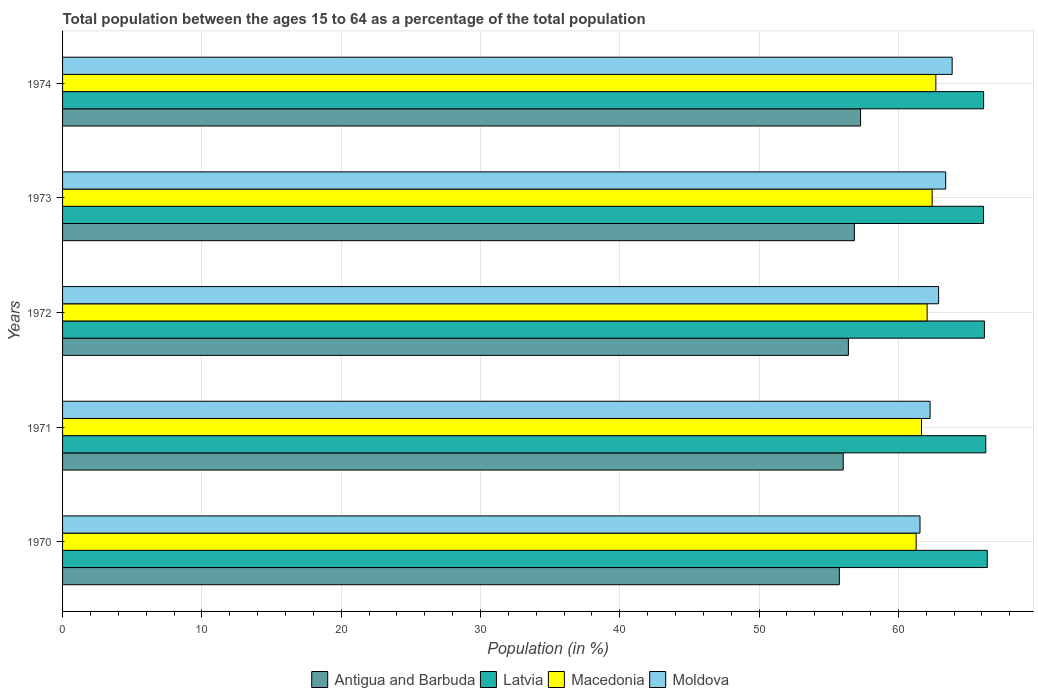How many groups of bars are there?
Offer a terse response. 5. Are the number of bars per tick equal to the number of legend labels?
Give a very brief answer. Yes. How many bars are there on the 2nd tick from the bottom?
Ensure brevity in your answer.  4. What is the label of the 4th group of bars from the top?
Ensure brevity in your answer.  1971. What is the percentage of the population ages 15 to 64 in Macedonia in 1972?
Offer a terse response. 62.07. Across all years, what is the maximum percentage of the population ages 15 to 64 in Moldova?
Offer a terse response. 63.86. Across all years, what is the minimum percentage of the population ages 15 to 64 in Latvia?
Your answer should be very brief. 66.12. In which year was the percentage of the population ages 15 to 64 in Latvia maximum?
Make the answer very short. 1970. What is the total percentage of the population ages 15 to 64 in Macedonia in the graph?
Provide a short and direct response. 310.12. What is the difference between the percentage of the population ages 15 to 64 in Latvia in 1970 and that in 1973?
Provide a succinct answer. 0.27. What is the difference between the percentage of the population ages 15 to 64 in Latvia in 1971 and the percentage of the population ages 15 to 64 in Antigua and Barbuda in 1972?
Your response must be concise. 9.86. What is the average percentage of the population ages 15 to 64 in Latvia per year?
Give a very brief answer. 66.21. In the year 1971, what is the difference between the percentage of the population ages 15 to 64 in Moldova and percentage of the population ages 15 to 64 in Latvia?
Ensure brevity in your answer.  -4. What is the ratio of the percentage of the population ages 15 to 64 in Latvia in 1971 to that in 1973?
Make the answer very short. 1. Is the percentage of the population ages 15 to 64 in Moldova in 1970 less than that in 1973?
Your answer should be compact. Yes. What is the difference between the highest and the second highest percentage of the population ages 15 to 64 in Latvia?
Offer a very short reply. 0.11. What is the difference between the highest and the lowest percentage of the population ages 15 to 64 in Antigua and Barbuda?
Keep it short and to the point. 1.52. What does the 3rd bar from the top in 1970 represents?
Offer a very short reply. Latvia. What does the 3rd bar from the bottom in 1972 represents?
Offer a terse response. Macedonia. Are the values on the major ticks of X-axis written in scientific E-notation?
Provide a short and direct response. No. Does the graph contain any zero values?
Keep it short and to the point. No. Does the graph contain grids?
Provide a short and direct response. Yes. How many legend labels are there?
Provide a succinct answer. 4. What is the title of the graph?
Provide a succinct answer. Total population between the ages 15 to 64 as a percentage of the total population. What is the label or title of the X-axis?
Offer a terse response. Population (in %). What is the label or title of the Y-axis?
Your answer should be compact. Years. What is the Population (in %) of Antigua and Barbuda in 1970?
Make the answer very short. 55.76. What is the Population (in %) of Latvia in 1970?
Provide a short and direct response. 66.38. What is the Population (in %) in Macedonia in 1970?
Offer a very short reply. 61.28. What is the Population (in %) in Moldova in 1970?
Give a very brief answer. 61.55. What is the Population (in %) in Antigua and Barbuda in 1971?
Give a very brief answer. 56.04. What is the Population (in %) in Latvia in 1971?
Make the answer very short. 66.28. What is the Population (in %) in Macedonia in 1971?
Make the answer very short. 61.66. What is the Population (in %) in Moldova in 1971?
Give a very brief answer. 62.28. What is the Population (in %) in Antigua and Barbuda in 1972?
Provide a short and direct response. 56.41. What is the Population (in %) of Latvia in 1972?
Offer a very short reply. 66.18. What is the Population (in %) of Macedonia in 1972?
Make the answer very short. 62.07. What is the Population (in %) in Moldova in 1972?
Offer a very short reply. 62.89. What is the Population (in %) of Antigua and Barbuda in 1973?
Your answer should be compact. 56.84. What is the Population (in %) of Latvia in 1973?
Your answer should be very brief. 66.12. What is the Population (in %) of Macedonia in 1973?
Offer a terse response. 62.43. What is the Population (in %) of Moldova in 1973?
Offer a terse response. 63.4. What is the Population (in %) of Antigua and Barbuda in 1974?
Ensure brevity in your answer.  57.29. What is the Population (in %) in Latvia in 1974?
Give a very brief answer. 66.12. What is the Population (in %) in Macedonia in 1974?
Offer a terse response. 62.69. What is the Population (in %) in Moldova in 1974?
Give a very brief answer. 63.86. Across all years, what is the maximum Population (in %) of Antigua and Barbuda?
Provide a short and direct response. 57.29. Across all years, what is the maximum Population (in %) of Latvia?
Ensure brevity in your answer.  66.38. Across all years, what is the maximum Population (in %) in Macedonia?
Your answer should be compact. 62.69. Across all years, what is the maximum Population (in %) of Moldova?
Your response must be concise. 63.86. Across all years, what is the minimum Population (in %) of Antigua and Barbuda?
Offer a very short reply. 55.76. Across all years, what is the minimum Population (in %) of Latvia?
Give a very brief answer. 66.12. Across all years, what is the minimum Population (in %) in Macedonia?
Provide a short and direct response. 61.28. Across all years, what is the minimum Population (in %) of Moldova?
Provide a short and direct response. 61.55. What is the total Population (in %) in Antigua and Barbuda in the graph?
Your answer should be compact. 282.35. What is the total Population (in %) of Latvia in the graph?
Make the answer very short. 331.07. What is the total Population (in %) in Macedonia in the graph?
Make the answer very short. 310.12. What is the total Population (in %) in Moldova in the graph?
Your answer should be very brief. 313.98. What is the difference between the Population (in %) of Antigua and Barbuda in 1970 and that in 1971?
Give a very brief answer. -0.28. What is the difference between the Population (in %) in Latvia in 1970 and that in 1971?
Ensure brevity in your answer.  0.11. What is the difference between the Population (in %) in Macedonia in 1970 and that in 1971?
Keep it short and to the point. -0.38. What is the difference between the Population (in %) of Moldova in 1970 and that in 1971?
Provide a succinct answer. -0.73. What is the difference between the Population (in %) in Antigua and Barbuda in 1970 and that in 1972?
Make the answer very short. -0.65. What is the difference between the Population (in %) of Latvia in 1970 and that in 1972?
Offer a terse response. 0.2. What is the difference between the Population (in %) of Macedonia in 1970 and that in 1972?
Your answer should be compact. -0.79. What is the difference between the Population (in %) in Moldova in 1970 and that in 1972?
Provide a succinct answer. -1.34. What is the difference between the Population (in %) of Antigua and Barbuda in 1970 and that in 1973?
Make the answer very short. -1.08. What is the difference between the Population (in %) in Latvia in 1970 and that in 1973?
Provide a short and direct response. 0.27. What is the difference between the Population (in %) of Macedonia in 1970 and that in 1973?
Your answer should be compact. -1.15. What is the difference between the Population (in %) of Moldova in 1970 and that in 1973?
Offer a very short reply. -1.84. What is the difference between the Population (in %) in Antigua and Barbuda in 1970 and that in 1974?
Offer a very short reply. -1.52. What is the difference between the Population (in %) of Latvia in 1970 and that in 1974?
Offer a very short reply. 0.26. What is the difference between the Population (in %) of Macedonia in 1970 and that in 1974?
Keep it short and to the point. -1.41. What is the difference between the Population (in %) of Moldova in 1970 and that in 1974?
Provide a succinct answer. -2.31. What is the difference between the Population (in %) in Antigua and Barbuda in 1971 and that in 1972?
Your answer should be very brief. -0.37. What is the difference between the Population (in %) of Latvia in 1971 and that in 1972?
Your response must be concise. 0.1. What is the difference between the Population (in %) of Macedonia in 1971 and that in 1972?
Offer a terse response. -0.4. What is the difference between the Population (in %) in Moldova in 1971 and that in 1972?
Offer a terse response. -0.61. What is the difference between the Population (in %) of Antigua and Barbuda in 1971 and that in 1973?
Ensure brevity in your answer.  -0.8. What is the difference between the Population (in %) in Latvia in 1971 and that in 1973?
Make the answer very short. 0.16. What is the difference between the Population (in %) of Macedonia in 1971 and that in 1973?
Your response must be concise. -0.77. What is the difference between the Population (in %) in Moldova in 1971 and that in 1973?
Provide a succinct answer. -1.12. What is the difference between the Population (in %) in Antigua and Barbuda in 1971 and that in 1974?
Offer a very short reply. -1.24. What is the difference between the Population (in %) in Latvia in 1971 and that in 1974?
Give a very brief answer. 0.16. What is the difference between the Population (in %) of Macedonia in 1971 and that in 1974?
Give a very brief answer. -1.03. What is the difference between the Population (in %) in Moldova in 1971 and that in 1974?
Give a very brief answer. -1.58. What is the difference between the Population (in %) in Antigua and Barbuda in 1972 and that in 1973?
Your answer should be very brief. -0.43. What is the difference between the Population (in %) of Latvia in 1972 and that in 1973?
Make the answer very short. 0.06. What is the difference between the Population (in %) in Macedonia in 1972 and that in 1973?
Keep it short and to the point. -0.36. What is the difference between the Population (in %) in Moldova in 1972 and that in 1973?
Provide a short and direct response. -0.51. What is the difference between the Population (in %) in Antigua and Barbuda in 1972 and that in 1974?
Provide a short and direct response. -0.87. What is the difference between the Population (in %) of Latvia in 1972 and that in 1974?
Give a very brief answer. 0.06. What is the difference between the Population (in %) in Macedonia in 1972 and that in 1974?
Keep it short and to the point. -0.63. What is the difference between the Population (in %) in Moldova in 1972 and that in 1974?
Your answer should be very brief. -0.97. What is the difference between the Population (in %) in Antigua and Barbuda in 1973 and that in 1974?
Provide a succinct answer. -0.44. What is the difference between the Population (in %) in Latvia in 1973 and that in 1974?
Your answer should be very brief. -0. What is the difference between the Population (in %) in Macedonia in 1973 and that in 1974?
Ensure brevity in your answer.  -0.26. What is the difference between the Population (in %) of Moldova in 1973 and that in 1974?
Your response must be concise. -0.46. What is the difference between the Population (in %) in Antigua and Barbuda in 1970 and the Population (in %) in Latvia in 1971?
Ensure brevity in your answer.  -10.51. What is the difference between the Population (in %) of Antigua and Barbuda in 1970 and the Population (in %) of Macedonia in 1971?
Give a very brief answer. -5.9. What is the difference between the Population (in %) in Antigua and Barbuda in 1970 and the Population (in %) in Moldova in 1971?
Give a very brief answer. -6.52. What is the difference between the Population (in %) in Latvia in 1970 and the Population (in %) in Macedonia in 1971?
Ensure brevity in your answer.  4.72. What is the difference between the Population (in %) in Latvia in 1970 and the Population (in %) in Moldova in 1971?
Give a very brief answer. 4.1. What is the difference between the Population (in %) in Macedonia in 1970 and the Population (in %) in Moldova in 1971?
Your response must be concise. -1. What is the difference between the Population (in %) in Antigua and Barbuda in 1970 and the Population (in %) in Latvia in 1972?
Ensure brevity in your answer.  -10.42. What is the difference between the Population (in %) in Antigua and Barbuda in 1970 and the Population (in %) in Macedonia in 1972?
Give a very brief answer. -6.3. What is the difference between the Population (in %) of Antigua and Barbuda in 1970 and the Population (in %) of Moldova in 1972?
Provide a short and direct response. -7.13. What is the difference between the Population (in %) of Latvia in 1970 and the Population (in %) of Macedonia in 1972?
Make the answer very short. 4.32. What is the difference between the Population (in %) in Latvia in 1970 and the Population (in %) in Moldova in 1972?
Your answer should be very brief. 3.49. What is the difference between the Population (in %) of Macedonia in 1970 and the Population (in %) of Moldova in 1972?
Provide a short and direct response. -1.61. What is the difference between the Population (in %) of Antigua and Barbuda in 1970 and the Population (in %) of Latvia in 1973?
Give a very brief answer. -10.35. What is the difference between the Population (in %) of Antigua and Barbuda in 1970 and the Population (in %) of Macedonia in 1973?
Provide a succinct answer. -6.66. What is the difference between the Population (in %) in Antigua and Barbuda in 1970 and the Population (in %) in Moldova in 1973?
Your answer should be compact. -7.64. What is the difference between the Population (in %) of Latvia in 1970 and the Population (in %) of Macedonia in 1973?
Offer a very short reply. 3.96. What is the difference between the Population (in %) of Latvia in 1970 and the Population (in %) of Moldova in 1973?
Offer a terse response. 2.98. What is the difference between the Population (in %) in Macedonia in 1970 and the Population (in %) in Moldova in 1973?
Provide a short and direct response. -2.12. What is the difference between the Population (in %) of Antigua and Barbuda in 1970 and the Population (in %) of Latvia in 1974?
Your answer should be very brief. -10.36. What is the difference between the Population (in %) in Antigua and Barbuda in 1970 and the Population (in %) in Macedonia in 1974?
Provide a succinct answer. -6.93. What is the difference between the Population (in %) of Antigua and Barbuda in 1970 and the Population (in %) of Moldova in 1974?
Give a very brief answer. -8.1. What is the difference between the Population (in %) of Latvia in 1970 and the Population (in %) of Macedonia in 1974?
Offer a very short reply. 3.69. What is the difference between the Population (in %) of Latvia in 1970 and the Population (in %) of Moldova in 1974?
Make the answer very short. 2.52. What is the difference between the Population (in %) of Macedonia in 1970 and the Population (in %) of Moldova in 1974?
Your response must be concise. -2.58. What is the difference between the Population (in %) of Antigua and Barbuda in 1971 and the Population (in %) of Latvia in 1972?
Your response must be concise. -10.14. What is the difference between the Population (in %) in Antigua and Barbuda in 1971 and the Population (in %) in Macedonia in 1972?
Your answer should be compact. -6.02. What is the difference between the Population (in %) of Antigua and Barbuda in 1971 and the Population (in %) of Moldova in 1972?
Offer a very short reply. -6.85. What is the difference between the Population (in %) of Latvia in 1971 and the Population (in %) of Macedonia in 1972?
Your answer should be compact. 4.21. What is the difference between the Population (in %) of Latvia in 1971 and the Population (in %) of Moldova in 1972?
Offer a terse response. 3.38. What is the difference between the Population (in %) in Macedonia in 1971 and the Population (in %) in Moldova in 1972?
Your answer should be compact. -1.23. What is the difference between the Population (in %) in Antigua and Barbuda in 1971 and the Population (in %) in Latvia in 1973?
Provide a succinct answer. -10.07. What is the difference between the Population (in %) of Antigua and Barbuda in 1971 and the Population (in %) of Macedonia in 1973?
Give a very brief answer. -6.38. What is the difference between the Population (in %) in Antigua and Barbuda in 1971 and the Population (in %) in Moldova in 1973?
Offer a very short reply. -7.36. What is the difference between the Population (in %) in Latvia in 1971 and the Population (in %) in Macedonia in 1973?
Your answer should be compact. 3.85. What is the difference between the Population (in %) of Latvia in 1971 and the Population (in %) of Moldova in 1973?
Your answer should be very brief. 2.88. What is the difference between the Population (in %) of Macedonia in 1971 and the Population (in %) of Moldova in 1973?
Make the answer very short. -1.74. What is the difference between the Population (in %) of Antigua and Barbuda in 1971 and the Population (in %) of Latvia in 1974?
Your response must be concise. -10.08. What is the difference between the Population (in %) of Antigua and Barbuda in 1971 and the Population (in %) of Macedonia in 1974?
Provide a short and direct response. -6.65. What is the difference between the Population (in %) in Antigua and Barbuda in 1971 and the Population (in %) in Moldova in 1974?
Provide a succinct answer. -7.82. What is the difference between the Population (in %) in Latvia in 1971 and the Population (in %) in Macedonia in 1974?
Provide a succinct answer. 3.58. What is the difference between the Population (in %) of Latvia in 1971 and the Population (in %) of Moldova in 1974?
Provide a succinct answer. 2.41. What is the difference between the Population (in %) in Macedonia in 1971 and the Population (in %) in Moldova in 1974?
Make the answer very short. -2.2. What is the difference between the Population (in %) in Antigua and Barbuda in 1972 and the Population (in %) in Latvia in 1973?
Your answer should be very brief. -9.7. What is the difference between the Population (in %) in Antigua and Barbuda in 1972 and the Population (in %) in Macedonia in 1973?
Provide a short and direct response. -6.01. What is the difference between the Population (in %) of Antigua and Barbuda in 1972 and the Population (in %) of Moldova in 1973?
Your answer should be compact. -6.99. What is the difference between the Population (in %) of Latvia in 1972 and the Population (in %) of Macedonia in 1973?
Your answer should be compact. 3.75. What is the difference between the Population (in %) in Latvia in 1972 and the Population (in %) in Moldova in 1973?
Ensure brevity in your answer.  2.78. What is the difference between the Population (in %) in Macedonia in 1972 and the Population (in %) in Moldova in 1973?
Provide a short and direct response. -1.33. What is the difference between the Population (in %) of Antigua and Barbuda in 1972 and the Population (in %) of Latvia in 1974?
Give a very brief answer. -9.71. What is the difference between the Population (in %) of Antigua and Barbuda in 1972 and the Population (in %) of Macedonia in 1974?
Your answer should be compact. -6.28. What is the difference between the Population (in %) of Antigua and Barbuda in 1972 and the Population (in %) of Moldova in 1974?
Make the answer very short. -7.45. What is the difference between the Population (in %) of Latvia in 1972 and the Population (in %) of Macedonia in 1974?
Offer a very short reply. 3.49. What is the difference between the Population (in %) in Latvia in 1972 and the Population (in %) in Moldova in 1974?
Offer a very short reply. 2.32. What is the difference between the Population (in %) in Macedonia in 1972 and the Population (in %) in Moldova in 1974?
Provide a succinct answer. -1.8. What is the difference between the Population (in %) in Antigua and Barbuda in 1973 and the Population (in %) in Latvia in 1974?
Offer a terse response. -9.28. What is the difference between the Population (in %) in Antigua and Barbuda in 1973 and the Population (in %) in Macedonia in 1974?
Make the answer very short. -5.85. What is the difference between the Population (in %) of Antigua and Barbuda in 1973 and the Population (in %) of Moldova in 1974?
Give a very brief answer. -7.02. What is the difference between the Population (in %) in Latvia in 1973 and the Population (in %) in Macedonia in 1974?
Keep it short and to the point. 3.42. What is the difference between the Population (in %) of Latvia in 1973 and the Population (in %) of Moldova in 1974?
Make the answer very short. 2.25. What is the difference between the Population (in %) in Macedonia in 1973 and the Population (in %) in Moldova in 1974?
Offer a very short reply. -1.44. What is the average Population (in %) of Antigua and Barbuda per year?
Make the answer very short. 56.47. What is the average Population (in %) in Latvia per year?
Give a very brief answer. 66.21. What is the average Population (in %) of Macedonia per year?
Provide a succinct answer. 62.02. What is the average Population (in %) of Moldova per year?
Offer a very short reply. 62.8. In the year 1970, what is the difference between the Population (in %) of Antigua and Barbuda and Population (in %) of Latvia?
Your response must be concise. -10.62. In the year 1970, what is the difference between the Population (in %) in Antigua and Barbuda and Population (in %) in Macedonia?
Offer a terse response. -5.52. In the year 1970, what is the difference between the Population (in %) of Antigua and Barbuda and Population (in %) of Moldova?
Make the answer very short. -5.79. In the year 1970, what is the difference between the Population (in %) in Latvia and Population (in %) in Macedonia?
Ensure brevity in your answer.  5.1. In the year 1970, what is the difference between the Population (in %) in Latvia and Population (in %) in Moldova?
Keep it short and to the point. 4.83. In the year 1970, what is the difference between the Population (in %) in Macedonia and Population (in %) in Moldova?
Give a very brief answer. -0.28. In the year 1971, what is the difference between the Population (in %) of Antigua and Barbuda and Population (in %) of Latvia?
Make the answer very short. -10.23. In the year 1971, what is the difference between the Population (in %) in Antigua and Barbuda and Population (in %) in Macedonia?
Provide a short and direct response. -5.62. In the year 1971, what is the difference between the Population (in %) of Antigua and Barbuda and Population (in %) of Moldova?
Your answer should be compact. -6.24. In the year 1971, what is the difference between the Population (in %) of Latvia and Population (in %) of Macedonia?
Make the answer very short. 4.61. In the year 1971, what is the difference between the Population (in %) of Latvia and Population (in %) of Moldova?
Your answer should be very brief. 4. In the year 1971, what is the difference between the Population (in %) in Macedonia and Population (in %) in Moldova?
Provide a short and direct response. -0.62. In the year 1972, what is the difference between the Population (in %) of Antigua and Barbuda and Population (in %) of Latvia?
Your answer should be compact. -9.77. In the year 1972, what is the difference between the Population (in %) in Antigua and Barbuda and Population (in %) in Macedonia?
Your answer should be very brief. -5.65. In the year 1972, what is the difference between the Population (in %) of Antigua and Barbuda and Population (in %) of Moldova?
Provide a succinct answer. -6.48. In the year 1972, what is the difference between the Population (in %) in Latvia and Population (in %) in Macedonia?
Your answer should be compact. 4.11. In the year 1972, what is the difference between the Population (in %) in Latvia and Population (in %) in Moldova?
Ensure brevity in your answer.  3.29. In the year 1972, what is the difference between the Population (in %) of Macedonia and Population (in %) of Moldova?
Offer a very short reply. -0.83. In the year 1973, what is the difference between the Population (in %) of Antigua and Barbuda and Population (in %) of Latvia?
Your answer should be very brief. -9.27. In the year 1973, what is the difference between the Population (in %) in Antigua and Barbuda and Population (in %) in Macedonia?
Give a very brief answer. -5.58. In the year 1973, what is the difference between the Population (in %) of Antigua and Barbuda and Population (in %) of Moldova?
Ensure brevity in your answer.  -6.56. In the year 1973, what is the difference between the Population (in %) in Latvia and Population (in %) in Macedonia?
Provide a succinct answer. 3.69. In the year 1973, what is the difference between the Population (in %) of Latvia and Population (in %) of Moldova?
Offer a terse response. 2.72. In the year 1973, what is the difference between the Population (in %) of Macedonia and Population (in %) of Moldova?
Keep it short and to the point. -0.97. In the year 1974, what is the difference between the Population (in %) of Antigua and Barbuda and Population (in %) of Latvia?
Offer a very short reply. -8.83. In the year 1974, what is the difference between the Population (in %) of Antigua and Barbuda and Population (in %) of Macedonia?
Provide a succinct answer. -5.4. In the year 1974, what is the difference between the Population (in %) of Antigua and Barbuda and Population (in %) of Moldova?
Give a very brief answer. -6.58. In the year 1974, what is the difference between the Population (in %) in Latvia and Population (in %) in Macedonia?
Your answer should be very brief. 3.43. In the year 1974, what is the difference between the Population (in %) of Latvia and Population (in %) of Moldova?
Ensure brevity in your answer.  2.26. In the year 1974, what is the difference between the Population (in %) of Macedonia and Population (in %) of Moldova?
Provide a succinct answer. -1.17. What is the ratio of the Population (in %) of Antigua and Barbuda in 1970 to that in 1971?
Provide a succinct answer. 0.99. What is the ratio of the Population (in %) in Latvia in 1970 to that in 1971?
Make the answer very short. 1. What is the ratio of the Population (in %) of Moldova in 1970 to that in 1971?
Keep it short and to the point. 0.99. What is the ratio of the Population (in %) in Macedonia in 1970 to that in 1972?
Give a very brief answer. 0.99. What is the ratio of the Population (in %) of Moldova in 1970 to that in 1972?
Keep it short and to the point. 0.98. What is the ratio of the Population (in %) in Latvia in 1970 to that in 1973?
Offer a very short reply. 1. What is the ratio of the Population (in %) of Macedonia in 1970 to that in 1973?
Your answer should be very brief. 0.98. What is the ratio of the Population (in %) of Moldova in 1970 to that in 1973?
Give a very brief answer. 0.97. What is the ratio of the Population (in %) in Antigua and Barbuda in 1970 to that in 1974?
Provide a succinct answer. 0.97. What is the ratio of the Population (in %) of Latvia in 1970 to that in 1974?
Your response must be concise. 1. What is the ratio of the Population (in %) of Macedonia in 1970 to that in 1974?
Provide a succinct answer. 0.98. What is the ratio of the Population (in %) of Moldova in 1970 to that in 1974?
Your answer should be very brief. 0.96. What is the ratio of the Population (in %) in Antigua and Barbuda in 1971 to that in 1972?
Provide a succinct answer. 0.99. What is the ratio of the Population (in %) in Moldova in 1971 to that in 1972?
Offer a very short reply. 0.99. What is the ratio of the Population (in %) in Antigua and Barbuda in 1971 to that in 1973?
Give a very brief answer. 0.99. What is the ratio of the Population (in %) in Latvia in 1971 to that in 1973?
Your response must be concise. 1. What is the ratio of the Population (in %) of Moldova in 1971 to that in 1973?
Give a very brief answer. 0.98. What is the ratio of the Population (in %) in Antigua and Barbuda in 1971 to that in 1974?
Your answer should be very brief. 0.98. What is the ratio of the Population (in %) of Latvia in 1971 to that in 1974?
Keep it short and to the point. 1. What is the ratio of the Population (in %) in Macedonia in 1971 to that in 1974?
Your response must be concise. 0.98. What is the ratio of the Population (in %) in Moldova in 1971 to that in 1974?
Offer a very short reply. 0.98. What is the ratio of the Population (in %) of Latvia in 1972 to that in 1973?
Your response must be concise. 1. What is the ratio of the Population (in %) in Antigua and Barbuda in 1972 to that in 1974?
Your response must be concise. 0.98. What is the ratio of the Population (in %) in Macedonia in 1972 to that in 1974?
Your answer should be compact. 0.99. What is the ratio of the Population (in %) of Moldova in 1972 to that in 1974?
Your response must be concise. 0.98. What is the ratio of the Population (in %) of Antigua and Barbuda in 1973 to that in 1974?
Your response must be concise. 0.99. What is the ratio of the Population (in %) in Latvia in 1973 to that in 1974?
Your response must be concise. 1. What is the ratio of the Population (in %) in Moldova in 1973 to that in 1974?
Give a very brief answer. 0.99. What is the difference between the highest and the second highest Population (in %) of Antigua and Barbuda?
Your answer should be compact. 0.44. What is the difference between the highest and the second highest Population (in %) of Latvia?
Your answer should be compact. 0.11. What is the difference between the highest and the second highest Population (in %) of Macedonia?
Give a very brief answer. 0.26. What is the difference between the highest and the second highest Population (in %) in Moldova?
Give a very brief answer. 0.46. What is the difference between the highest and the lowest Population (in %) in Antigua and Barbuda?
Your answer should be very brief. 1.52. What is the difference between the highest and the lowest Population (in %) in Latvia?
Your answer should be very brief. 0.27. What is the difference between the highest and the lowest Population (in %) in Macedonia?
Offer a terse response. 1.41. What is the difference between the highest and the lowest Population (in %) of Moldova?
Provide a succinct answer. 2.31. 